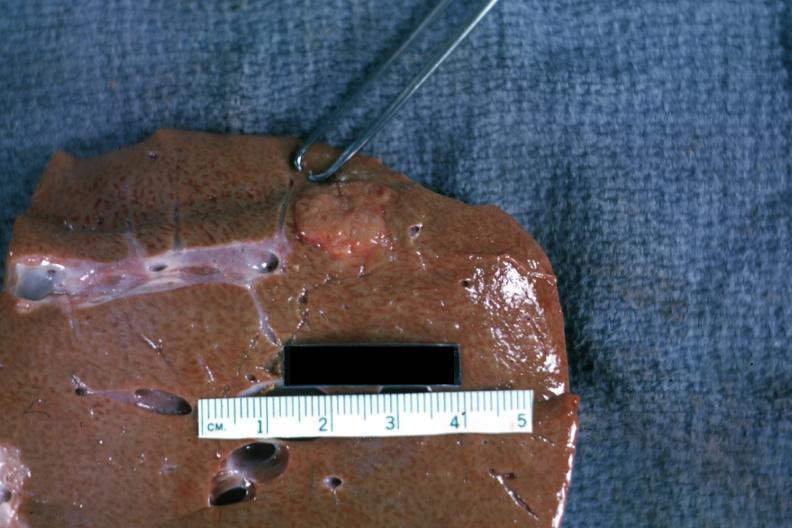s liver present?
Answer the question using a single word or phrase. Yes 